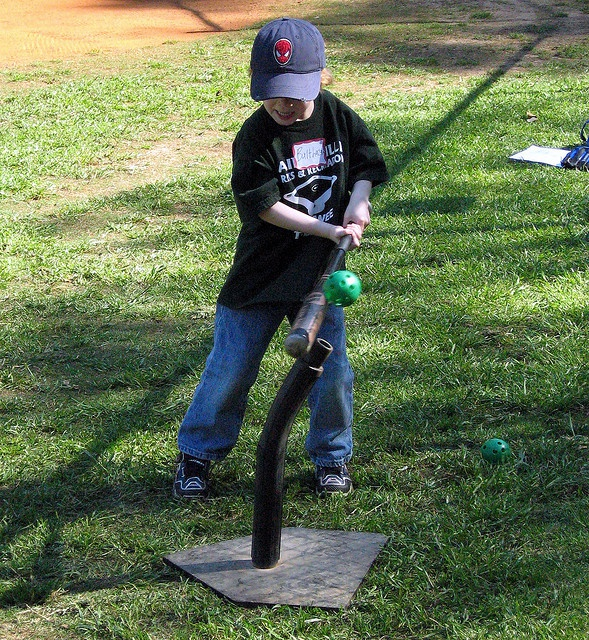Describe the objects in this image and their specific colors. I can see people in tan, black, navy, and gray tones, baseball bat in tan, gray, black, teal, and darkgray tones, sports ball in tan, darkgreen, teal, and green tones, and sports ball in tan, black, teal, and darkgreen tones in this image. 